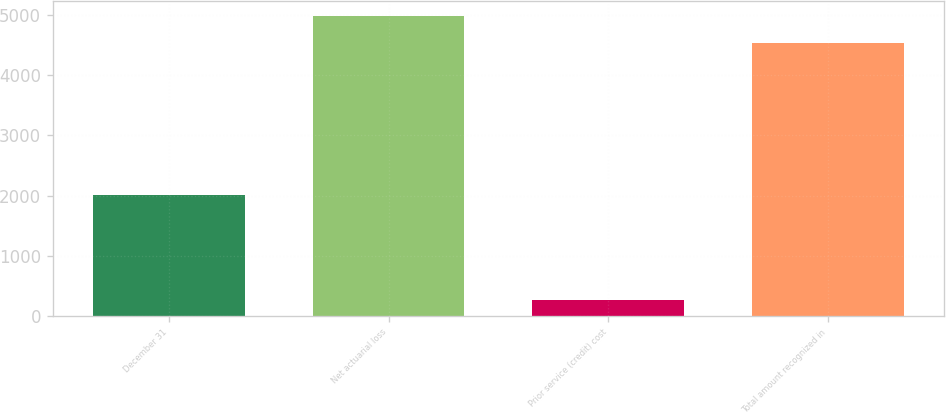Convert chart to OTSL. <chart><loc_0><loc_0><loc_500><loc_500><bar_chart><fcel>December 31<fcel>Net actuarial loss<fcel>Prior service (credit) cost<fcel>Total amount recognized in<nl><fcel>2011<fcel>4985.2<fcel>258<fcel>4532<nl></chart> 